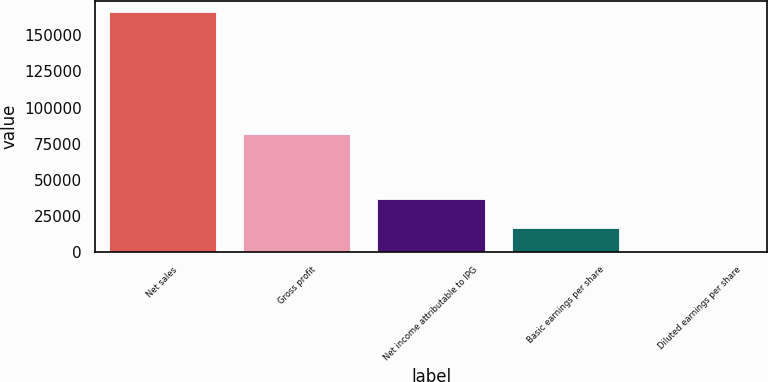<chart> <loc_0><loc_0><loc_500><loc_500><bar_chart><fcel>Net sales<fcel>Gross profit<fcel>Net income attributable to IPG<fcel>Basic earnings per share<fcel>Diluted earnings per share<nl><fcel>165859<fcel>81522<fcel>36595<fcel>16586.5<fcel>0.7<nl></chart> 